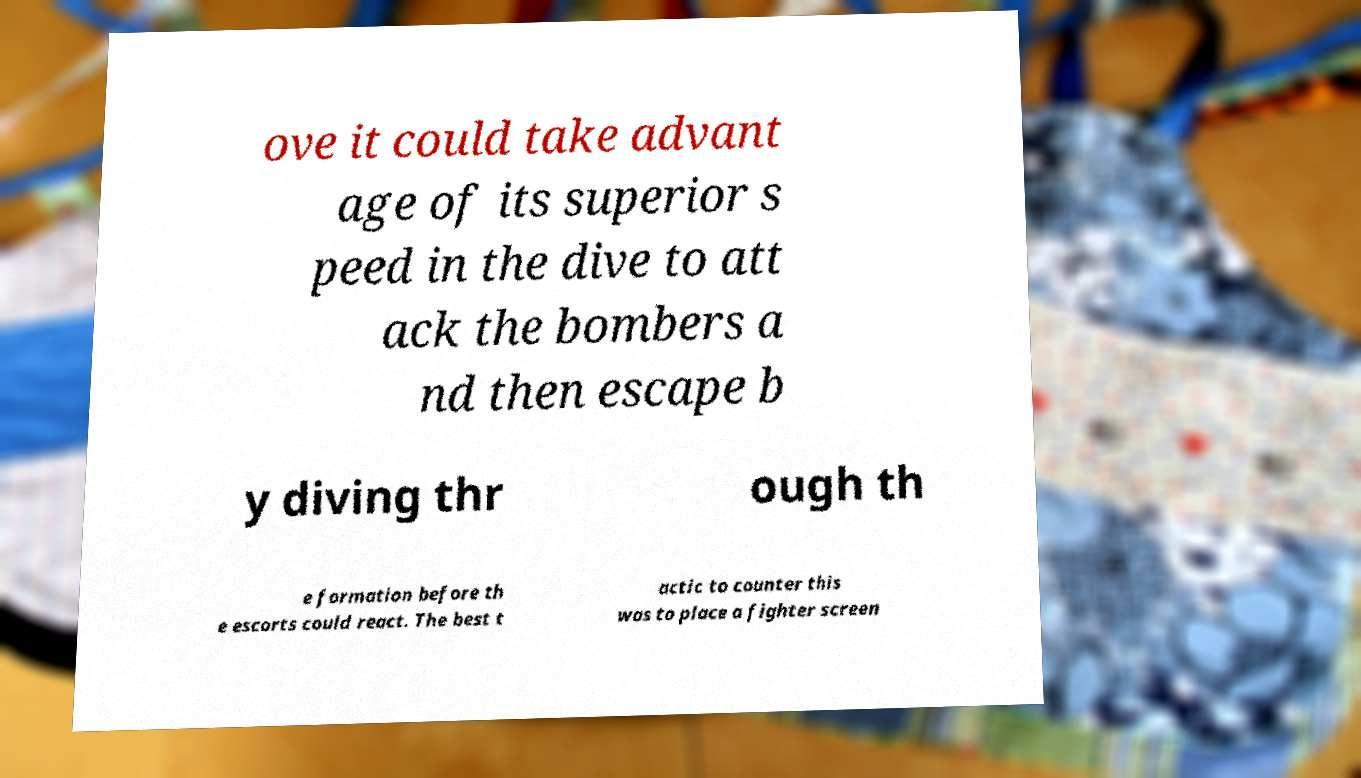There's text embedded in this image that I need extracted. Can you transcribe it verbatim? ove it could take advant age of its superior s peed in the dive to att ack the bombers a nd then escape b y diving thr ough th e formation before th e escorts could react. The best t actic to counter this was to place a fighter screen 